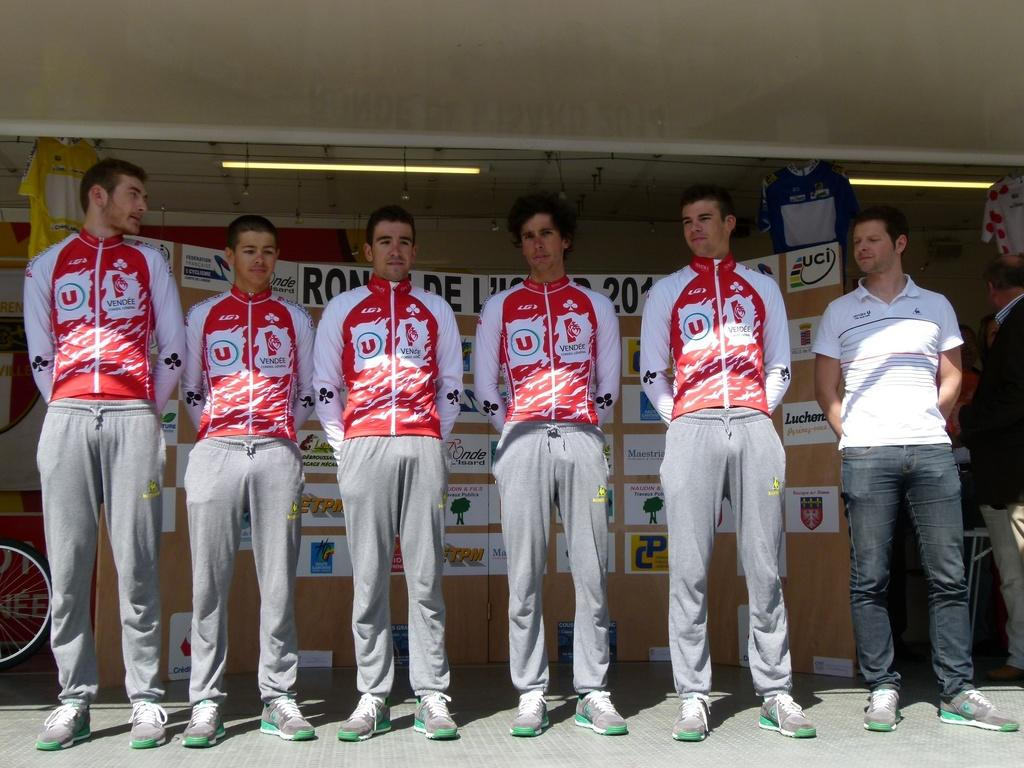<image>
Create a compact narrative representing the image presented. five team member from Vendee wearing matching red and white zip up jackets 